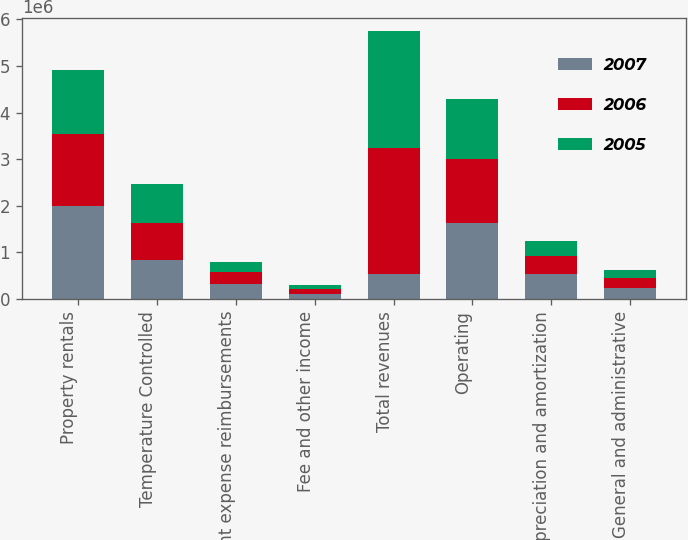<chart> <loc_0><loc_0><loc_500><loc_500><stacked_bar_chart><ecel><fcel>Property rentals<fcel>Temperature Controlled<fcel>Tenant expense reimbursements<fcel>Fee and other income<fcel>Total revenues<fcel>Operating<fcel>Depreciation and amortization<fcel>General and administrative<nl><fcel>2007<fcel>1.98928e+06<fcel>847026<fcel>324034<fcel>110291<fcel>529761<fcel>1.63258e+06<fcel>529761<fcel>232068<nl><fcel>2006<fcel>1.557e+06<fcel>779110<fcel>261339<fcel>103587<fcel>2.70104e+06<fcel>1.36266e+06<fcel>395398<fcel>219239<nl><fcel>2005<fcel>1.37145e+06<fcel>846881<fcel>206923<fcel>94603<fcel>2.51986e+06<fcel>1.29485e+06<fcel>328811<fcel>177790<nl></chart> 